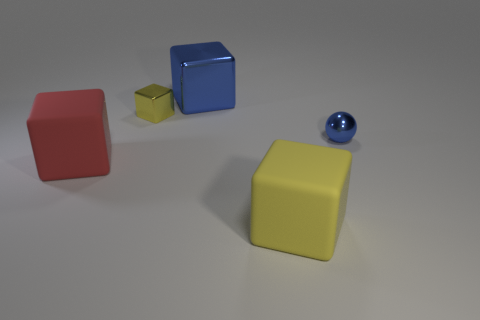Add 5 tiny yellow blocks. How many objects exist? 10 Subtract all blocks. How many objects are left? 1 Subtract 0 blue cylinders. How many objects are left? 5 Subtract all large gray cylinders. Subtract all yellow metallic things. How many objects are left? 4 Add 2 small blue objects. How many small blue objects are left? 3 Add 2 cubes. How many cubes exist? 6 